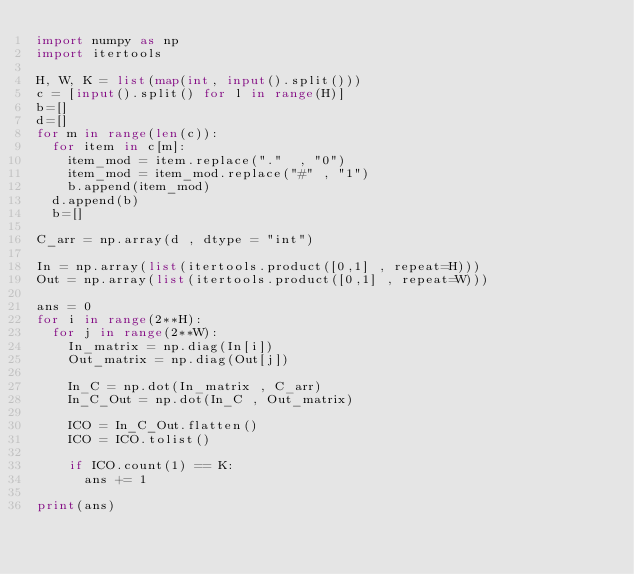Convert code to text. <code><loc_0><loc_0><loc_500><loc_500><_Python_>import numpy as np
import itertools

H, W, K = list(map(int, input().split())) 
c = [input().split() for l in range(H)]
b=[]
d=[]
for m in range(len(c)):
  for item in c[m]:
    item_mod = item.replace("."  , "0")
    item_mod = item_mod.replace("#" , "1")
    b.append(item_mod)
  d.append(b)
  b=[]

C_arr = np.array(d , dtype = "int")

In = np.array(list(itertools.product([0,1] , repeat=H)))
Out = np.array(list(itertools.product([0,1] , repeat=W)))

ans = 0
for i in range(2**H):
  for j in range(2**W):
    In_matrix = np.diag(In[i])
    Out_matrix = np.diag(Out[j])

    In_C = np.dot(In_matrix , C_arr)
    In_C_Out = np.dot(In_C , Out_matrix)

    ICO = In_C_Out.flatten()
    ICO = ICO.tolist()

    if ICO.count(1) == K:
      ans += 1

print(ans)</code> 